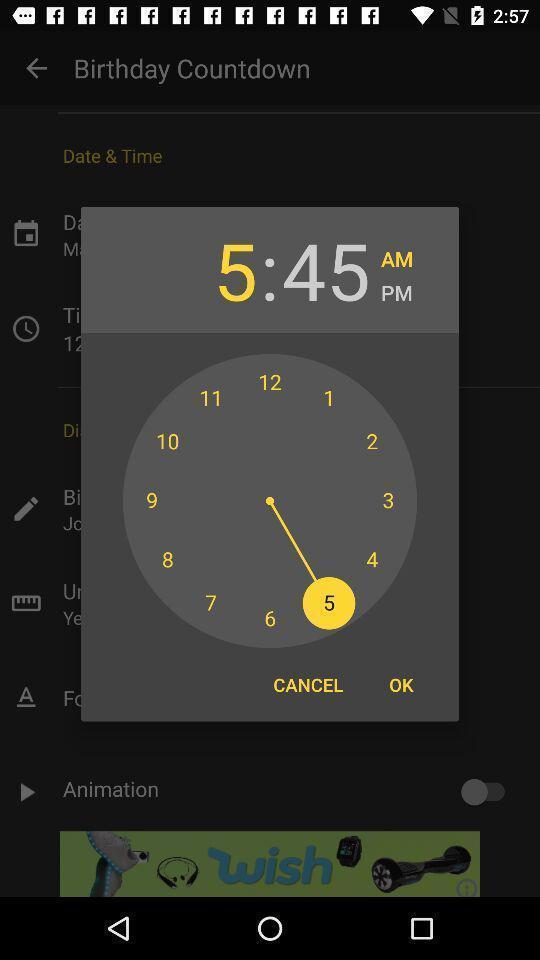Describe the content in this image. Screen shows clock to set time in birthday countdown application. 